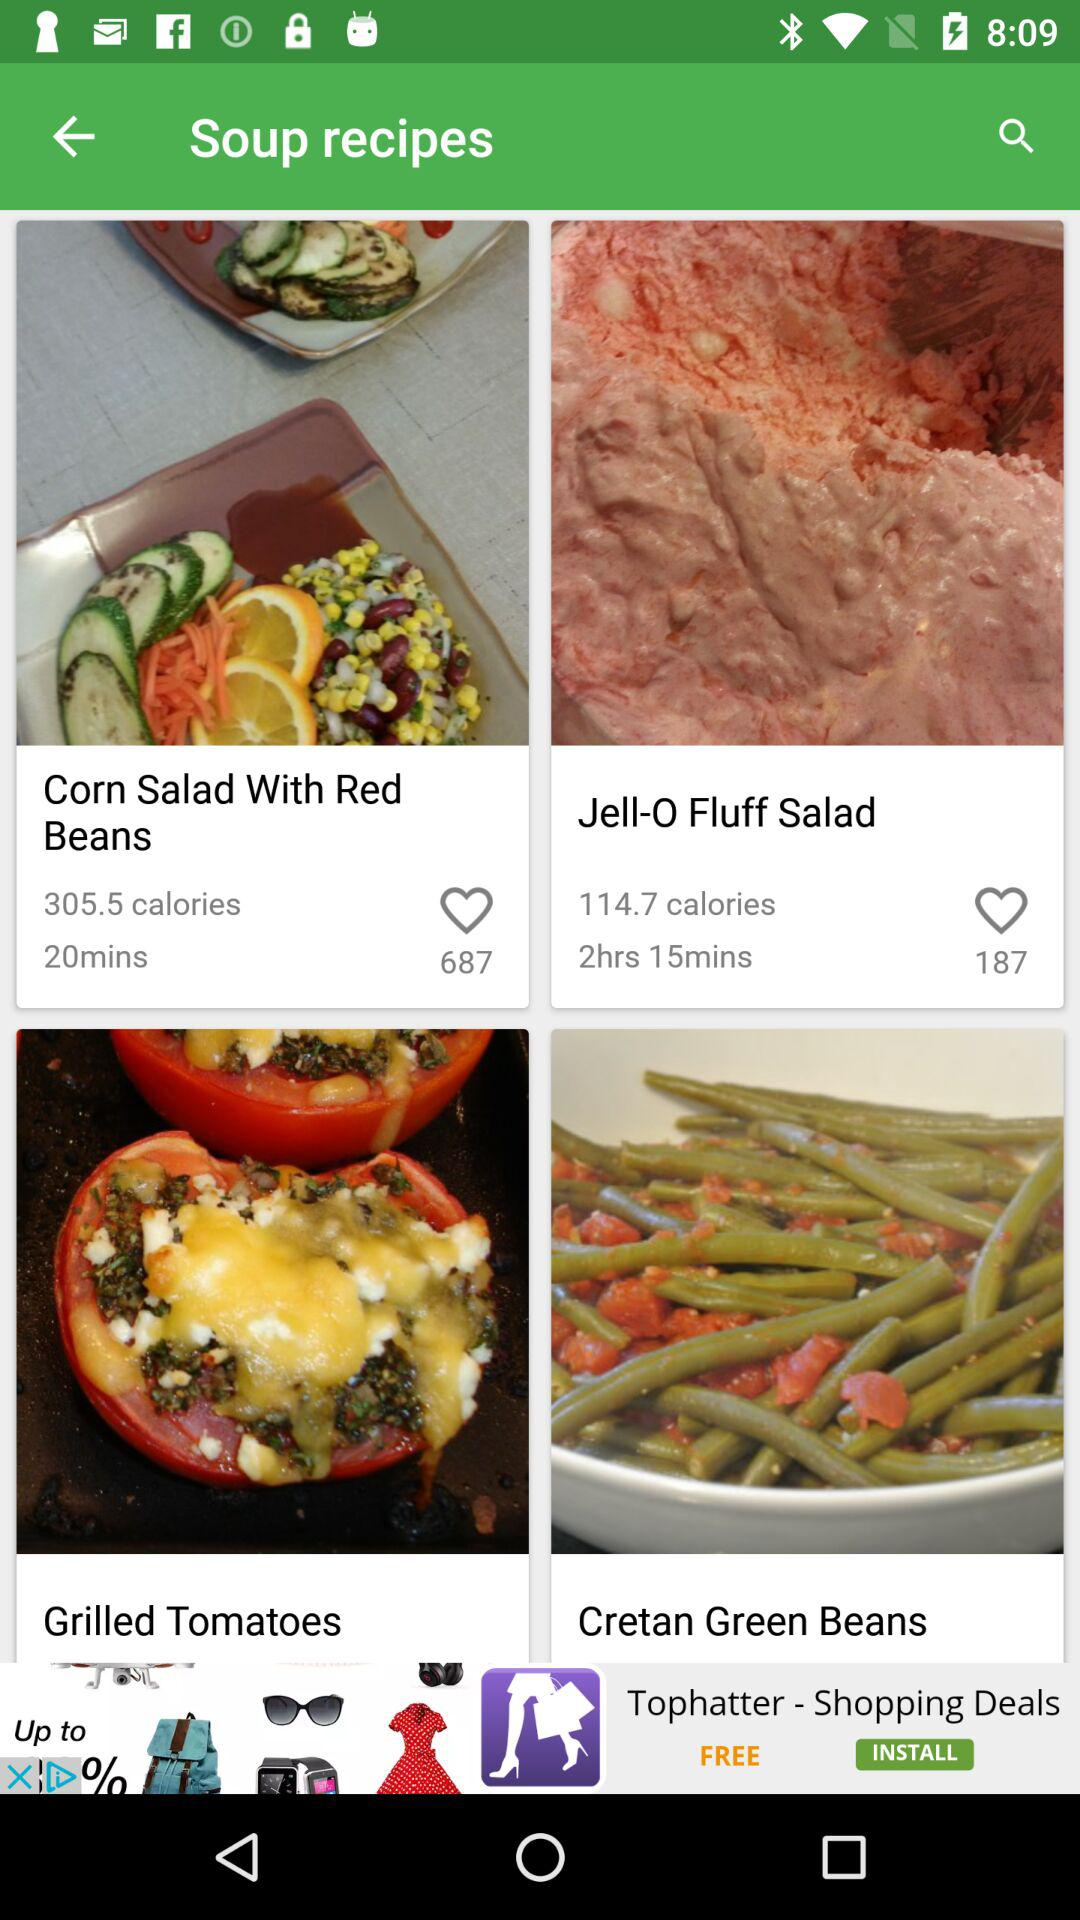How long will it take to make the "Jell-O Fluff Salad"? It will take 2 hours 15 minutes to make the "Jell-O Fluff Salad". 